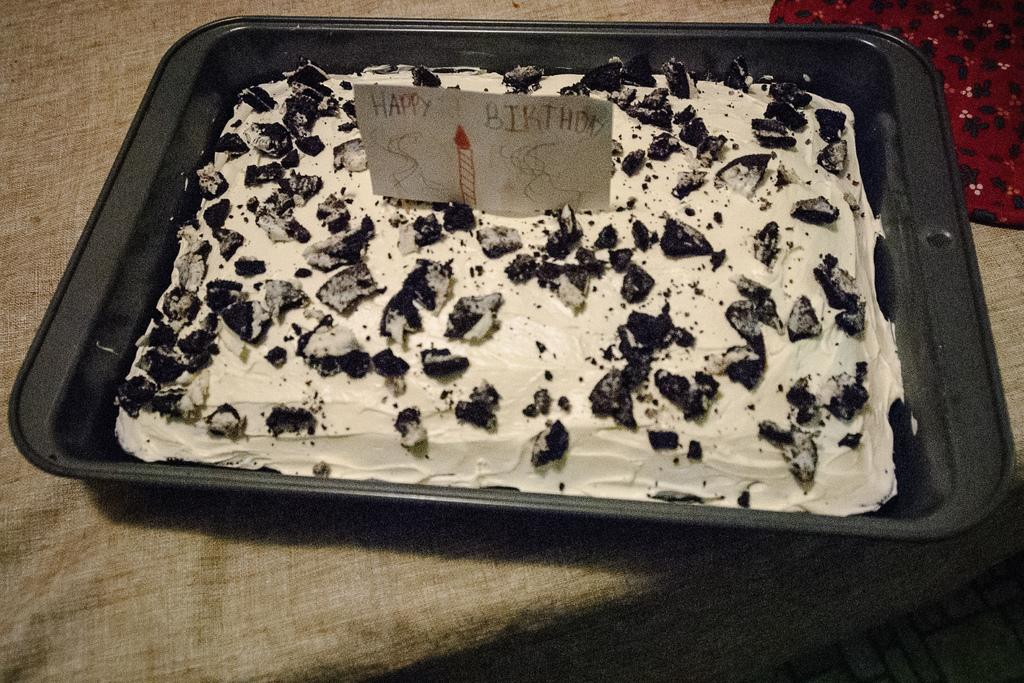What is the main object in the image? There is a black tray in the image. Where might the tray be located? The tray is likely on a table. What is on top of the tray? There is a cake on the tray. What is on the cake? Pieces of chocolate are on the cake. What is in the top right corner of the image? There is a cloth in the top right corner of the image. Where might the cloth be located? The cloth is likely on a table. Can you see the mom sitting on a chair in the image? There is no mom or chair present in the image. How many toads are on the cake? There are no toads present in the image. 